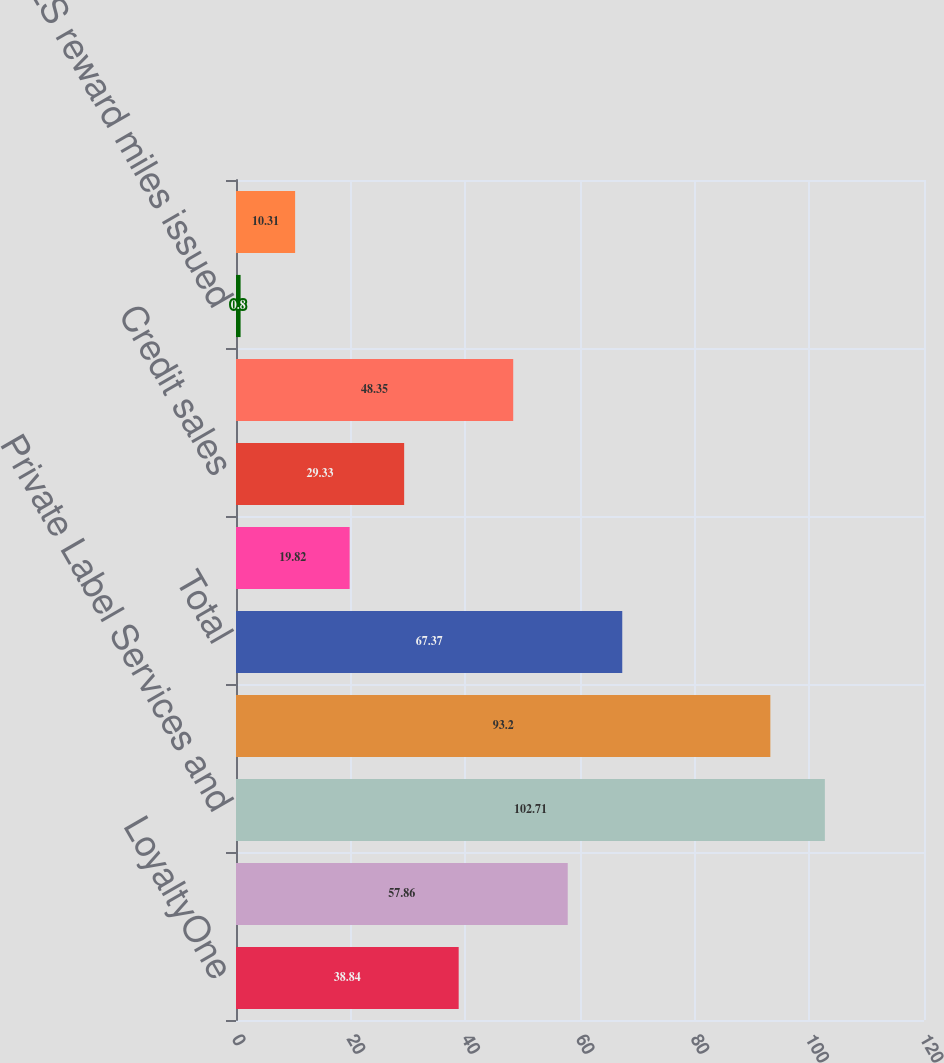Convert chart. <chart><loc_0><loc_0><loc_500><loc_500><bar_chart><fcel>LoyaltyOne<fcel>Epsilon<fcel>Private Label Services and<fcel>Corporate/Other<fcel>Total<fcel>Private label statements<fcel>Credit sales<fcel>Average credit card<fcel>AIR MILES reward miles issued<fcel>AIR MILES reward miles<nl><fcel>38.84<fcel>57.86<fcel>102.71<fcel>93.2<fcel>67.37<fcel>19.82<fcel>29.33<fcel>48.35<fcel>0.8<fcel>10.31<nl></chart> 